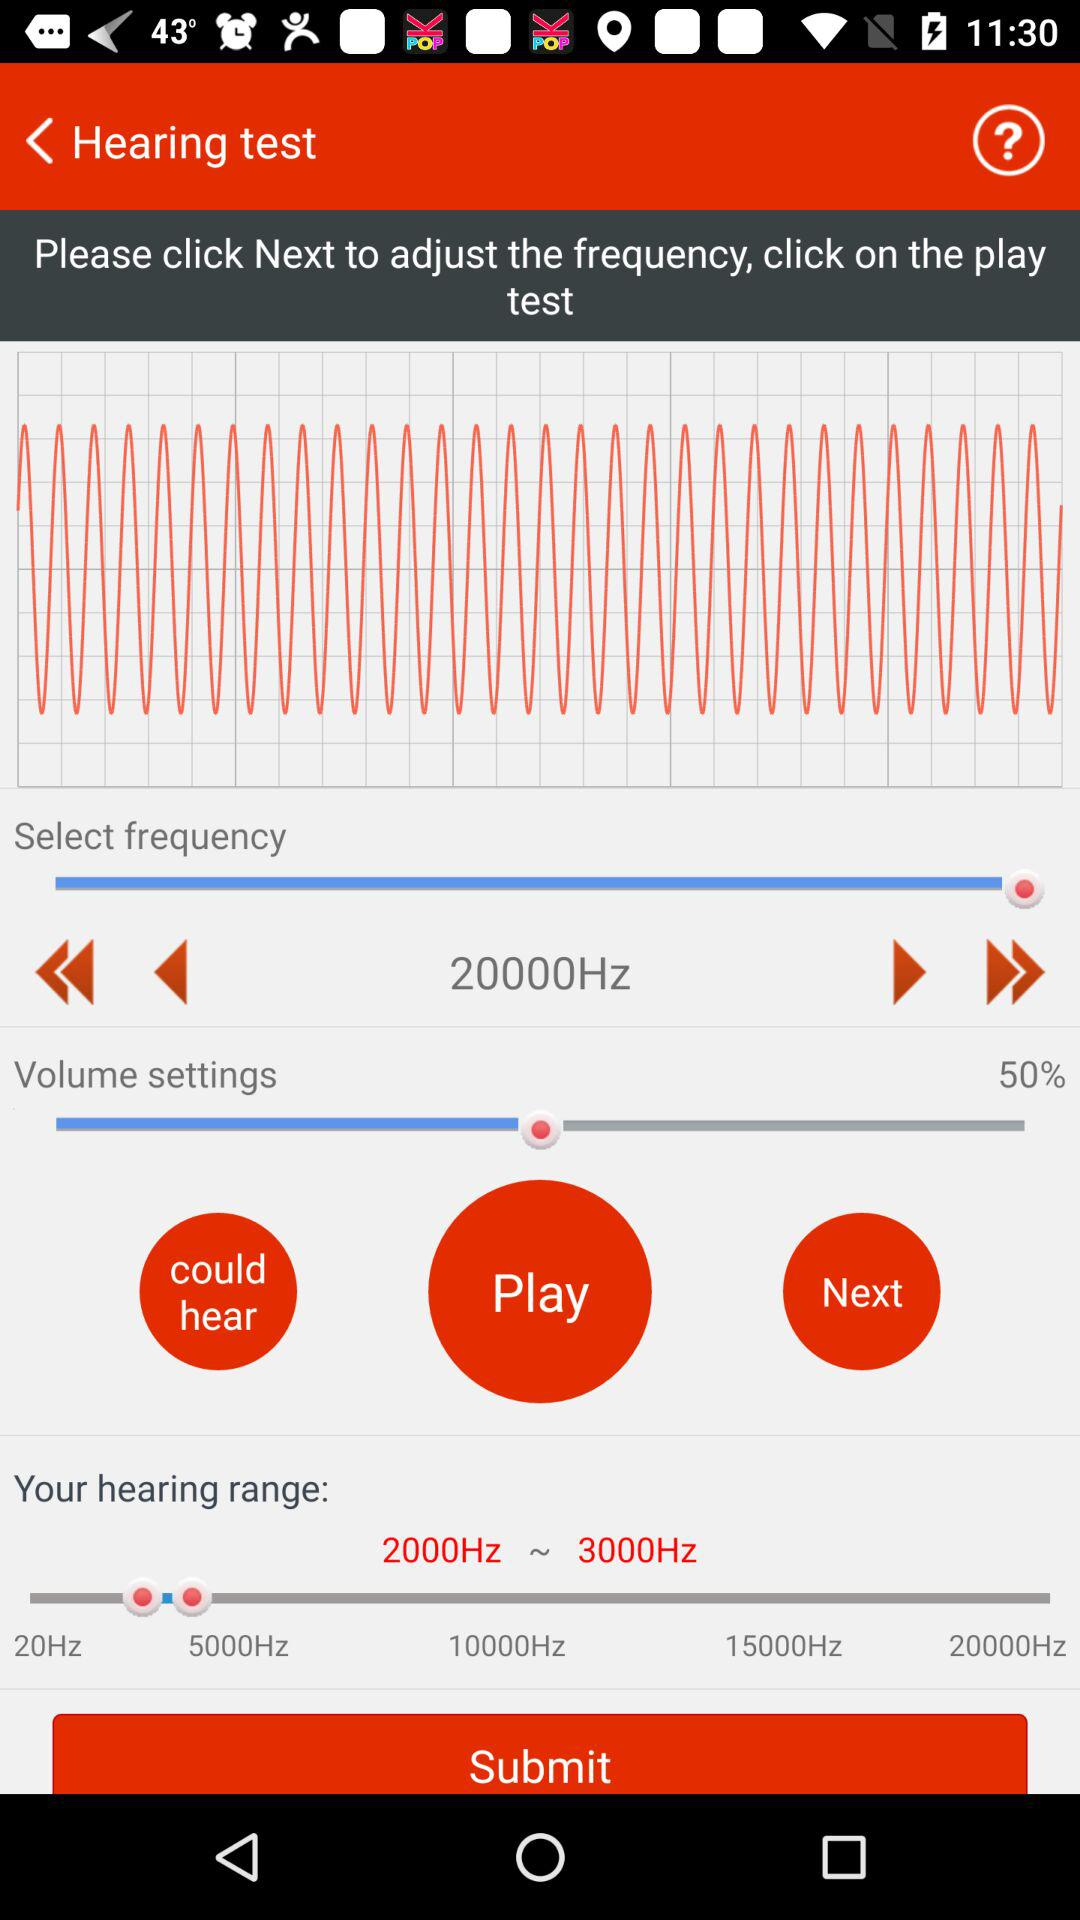At what percentage is the volume set? The percentage is 50. 